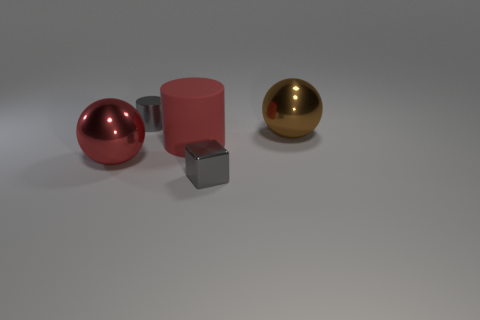Add 3 gray metallic cubes. How many objects exist? 8 Subtract all cylinders. How many objects are left? 3 Add 4 small shiny blocks. How many small shiny blocks are left? 5 Add 4 small brown rubber balls. How many small brown rubber balls exist? 4 Subtract 0 cyan blocks. How many objects are left? 5 Subtract all tiny cyan rubber balls. Subtract all small gray metal cubes. How many objects are left? 4 